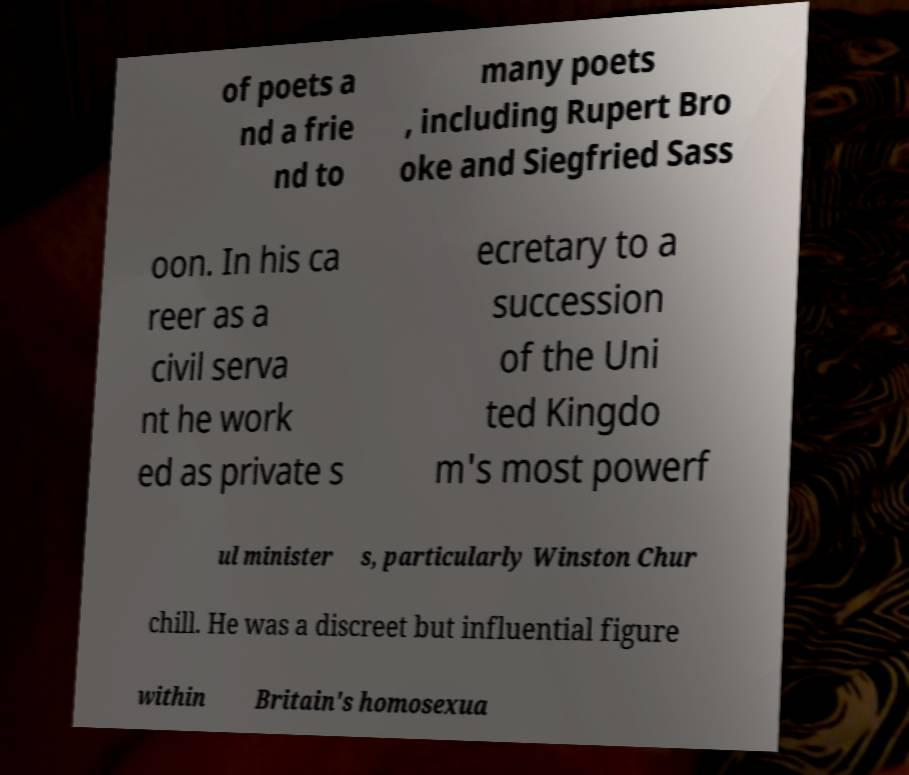Can you read and provide the text displayed in the image?This photo seems to have some interesting text. Can you extract and type it out for me? of poets a nd a frie nd to many poets , including Rupert Bro oke and Siegfried Sass oon. In his ca reer as a civil serva nt he work ed as private s ecretary to a succession of the Uni ted Kingdo m's most powerf ul minister s, particularly Winston Chur chill. He was a discreet but influential figure within Britain's homosexua 